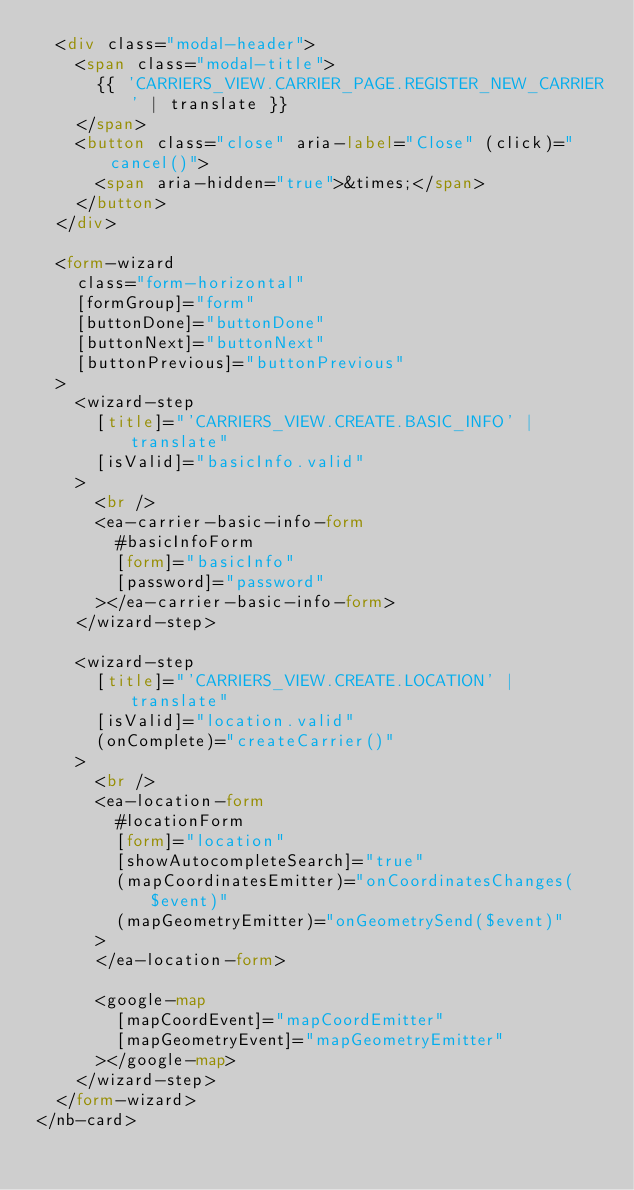Convert code to text. <code><loc_0><loc_0><loc_500><loc_500><_HTML_>	<div class="modal-header">
		<span class="modal-title">
			{{ 'CARRIERS_VIEW.CARRIER_PAGE.REGISTER_NEW_CARRIER' | translate }}
		</span>
		<button class="close" aria-label="Close" (click)="cancel()">
			<span aria-hidden="true">&times;</span>
		</button>
	</div>

	<form-wizard
		class="form-horizontal"
		[formGroup]="form"
		[buttonDone]="buttonDone"
		[buttonNext]="buttonNext"
		[buttonPrevious]="buttonPrevious"
	>
		<wizard-step
			[title]="'CARRIERS_VIEW.CREATE.BASIC_INFO' | translate"
			[isValid]="basicInfo.valid"
		>
			<br />
			<ea-carrier-basic-info-form
				#basicInfoForm
				[form]="basicInfo"
				[password]="password"
			></ea-carrier-basic-info-form>
		</wizard-step>

		<wizard-step
			[title]="'CARRIERS_VIEW.CREATE.LOCATION' | translate"
			[isValid]="location.valid"
			(onComplete)="createCarrier()"
		>
			<br />
			<ea-location-form
				#locationForm
				[form]="location"
				[showAutocompleteSearch]="true"
				(mapCoordinatesEmitter)="onCoordinatesChanges($event)"
				(mapGeometryEmitter)="onGeometrySend($event)"
			>
			</ea-location-form>

			<google-map
				[mapCoordEvent]="mapCoordEmitter"
				[mapGeometryEvent]="mapGeometryEmitter"
			></google-map>
		</wizard-step>
	</form-wizard>
</nb-card>
</code> 